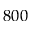<formula> <loc_0><loc_0><loc_500><loc_500>8 0 0</formula> 